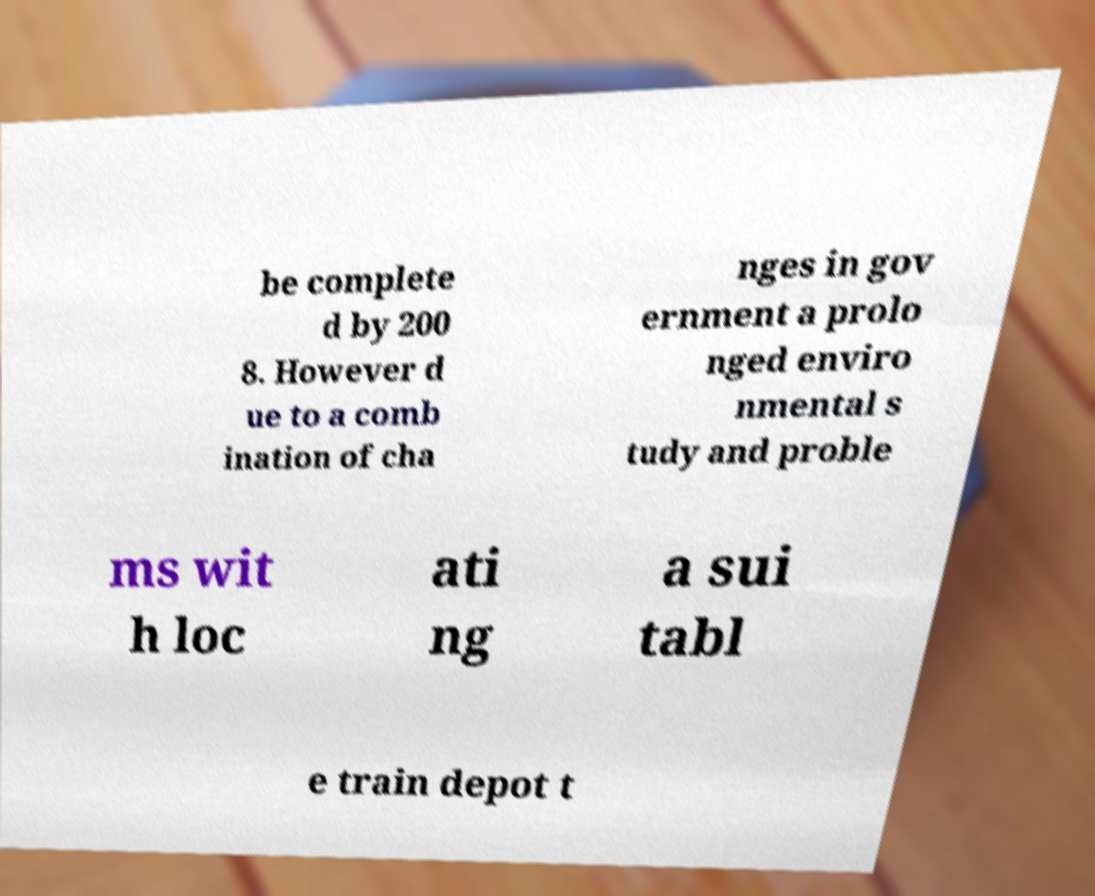Can you accurately transcribe the text from the provided image for me? be complete d by 200 8. However d ue to a comb ination of cha nges in gov ernment a prolo nged enviro nmental s tudy and proble ms wit h loc ati ng a sui tabl e train depot t 